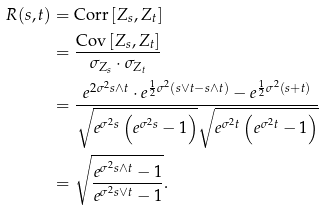Convert formula to latex. <formula><loc_0><loc_0><loc_500><loc_500>R ( s , t ) & = \text {Corr} \left [ Z _ { s } , Z _ { t } \right ] \\ & = \frac { \text {Cov} \left [ Z _ { s } , Z _ { t } \right ] } { \sigma _ { Z _ { s } } \cdot \sigma _ { Z _ { t } } } \\ & = \frac { e ^ { 2 \sigma ^ { 2 } s \wedge t } \cdot e ^ { \frac { 1 } { 2 } \sigma ^ { 2 } ( s \vee t - s \wedge t ) } - e ^ { \frac { 1 } { 2 } \sigma ^ { 2 } ( s + t ) } } { \sqrt { e ^ { \sigma ^ { 2 } s } \left ( e ^ { \sigma ^ { 2 } s } - 1 \right ) } \sqrt { e ^ { \sigma ^ { 2 } t } \left ( e ^ { \sigma ^ { 2 } t } - 1 \right ) } } \\ & = \sqrt { \frac { e ^ { \sigma ^ { 2 } s \wedge t } - 1 } { e ^ { \sigma ^ { 2 } s \vee t } - 1 } } .</formula> 